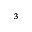Convert formula to latex. <formula><loc_0><loc_0><loc_500><loc_500>_ { 3 }</formula> 